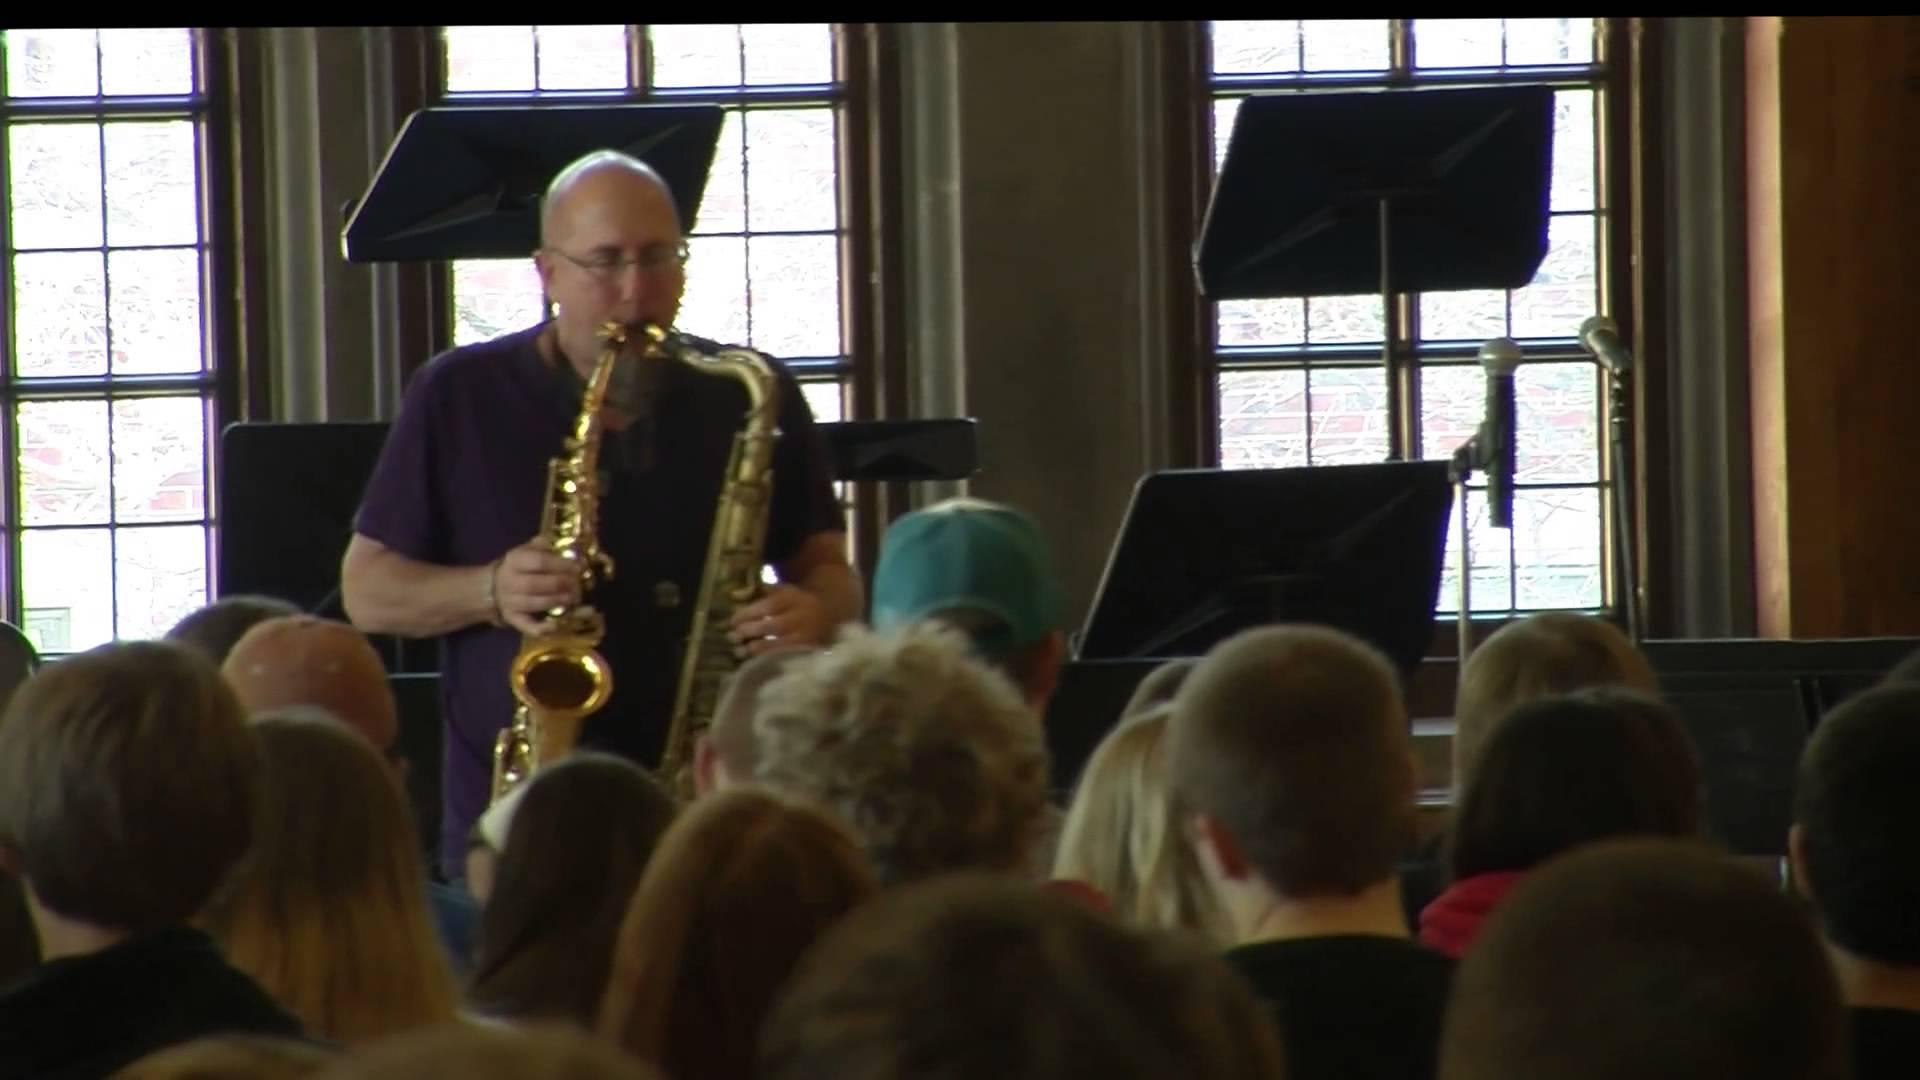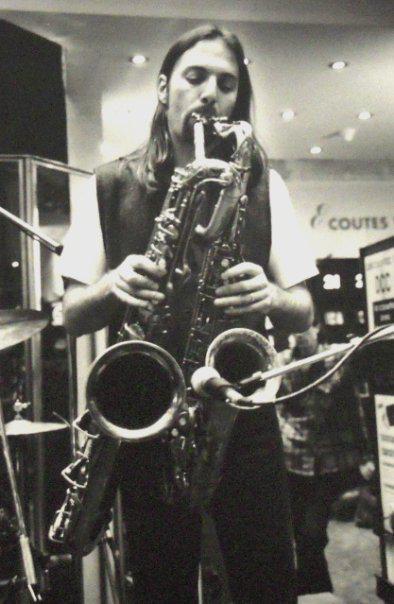The first image is the image on the left, the second image is the image on the right. Considering the images on both sides, is "There are three or more people clearly visible." valid? Answer yes or no. Yes. The first image is the image on the left, the second image is the image on the right. For the images shown, is this caption "An image shows a sax player wearing a tall black hat and glasses." true? Answer yes or no. No. 